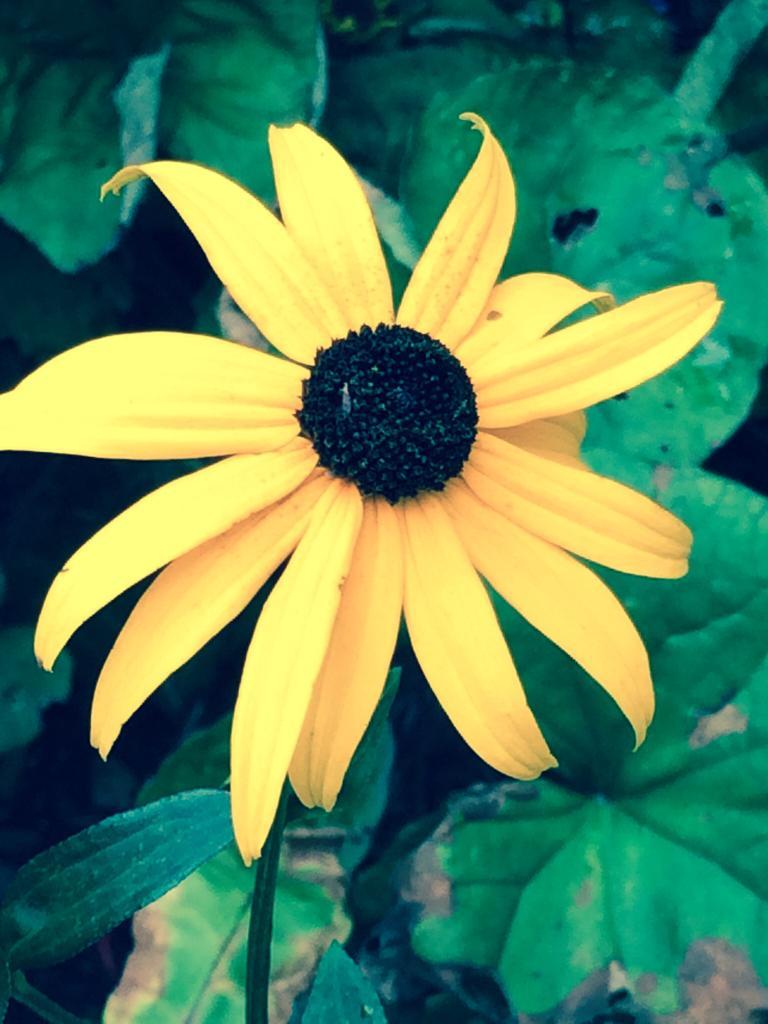How would you summarize this image in a sentence or two? In this picture I can see flower which have yellow petals. I can see green leaves. 